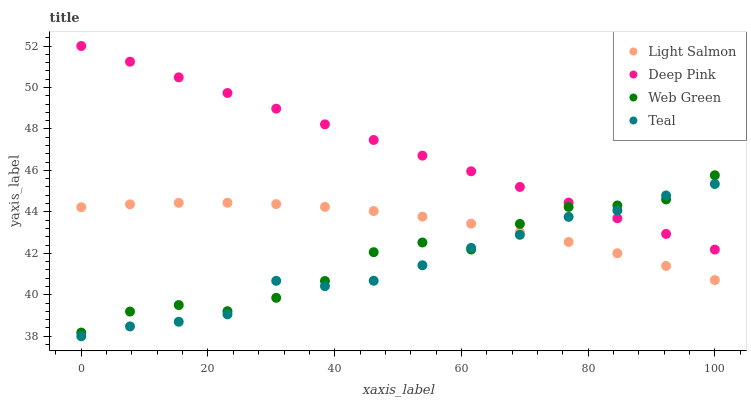Does Teal have the minimum area under the curve?
Answer yes or no. Yes. Does Deep Pink have the maximum area under the curve?
Answer yes or no. Yes. Does Deep Pink have the minimum area under the curve?
Answer yes or no. No. Does Teal have the maximum area under the curve?
Answer yes or no. No. Is Deep Pink the smoothest?
Answer yes or no. Yes. Is Web Green the roughest?
Answer yes or no. Yes. Is Teal the smoothest?
Answer yes or no. No. Is Teal the roughest?
Answer yes or no. No. Does Teal have the lowest value?
Answer yes or no. Yes. Does Deep Pink have the lowest value?
Answer yes or no. No. Does Deep Pink have the highest value?
Answer yes or no. Yes. Does Teal have the highest value?
Answer yes or no. No. Is Light Salmon less than Deep Pink?
Answer yes or no. Yes. Is Deep Pink greater than Light Salmon?
Answer yes or no. Yes. Does Teal intersect Light Salmon?
Answer yes or no. Yes. Is Teal less than Light Salmon?
Answer yes or no. No. Is Teal greater than Light Salmon?
Answer yes or no. No. Does Light Salmon intersect Deep Pink?
Answer yes or no. No. 